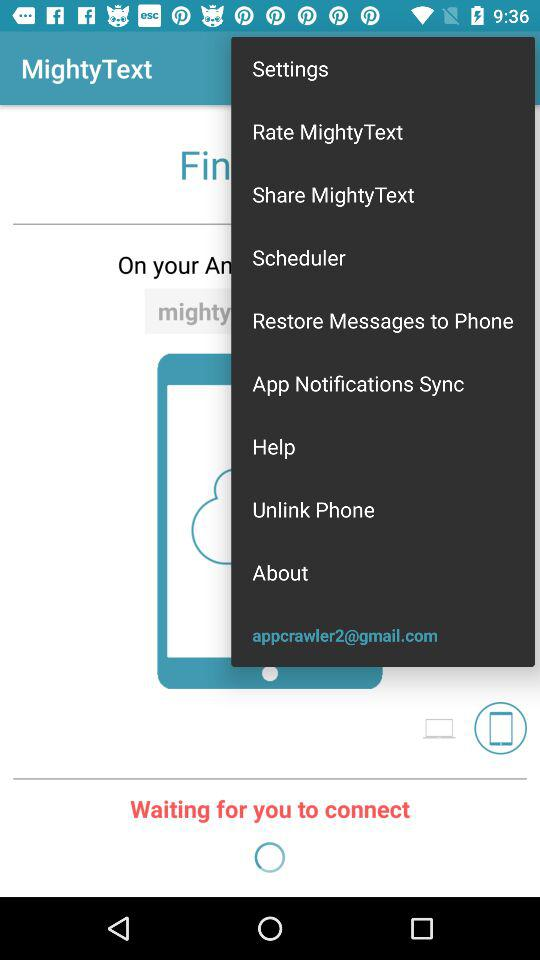What is the application Name? The application name is "MightyText". 